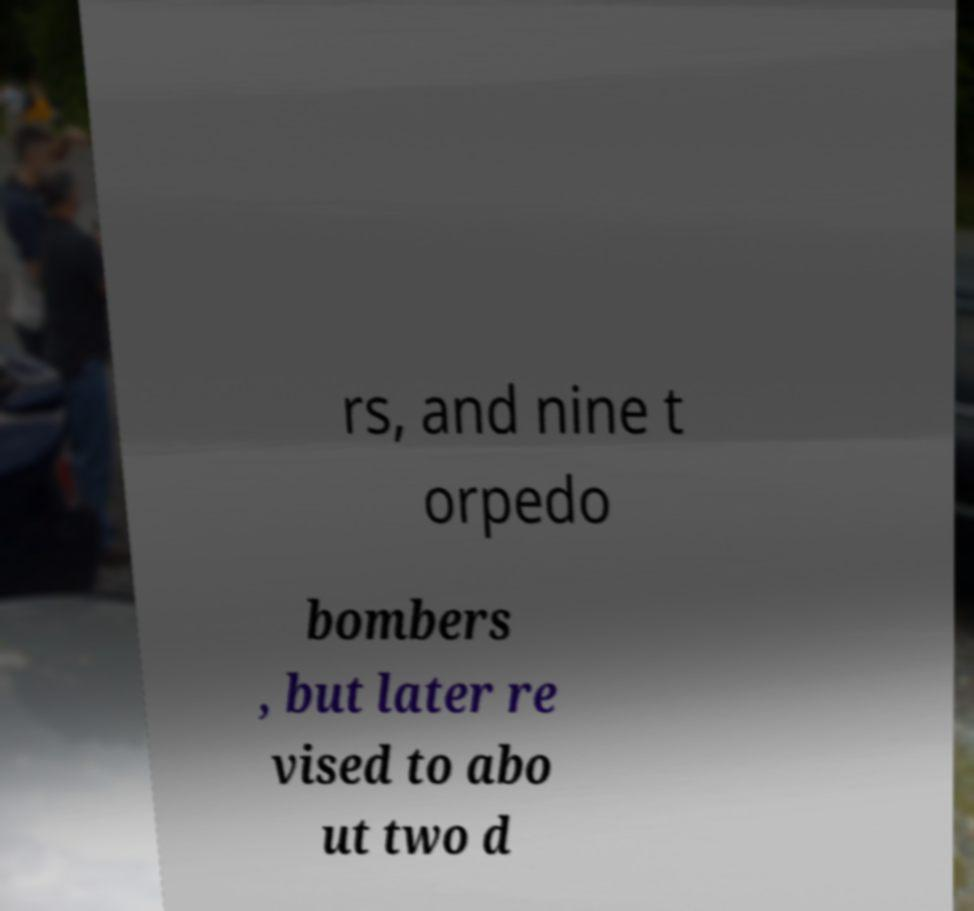Can you read and provide the text displayed in the image?This photo seems to have some interesting text. Can you extract and type it out for me? rs, and nine t orpedo bombers , but later re vised to abo ut two d 